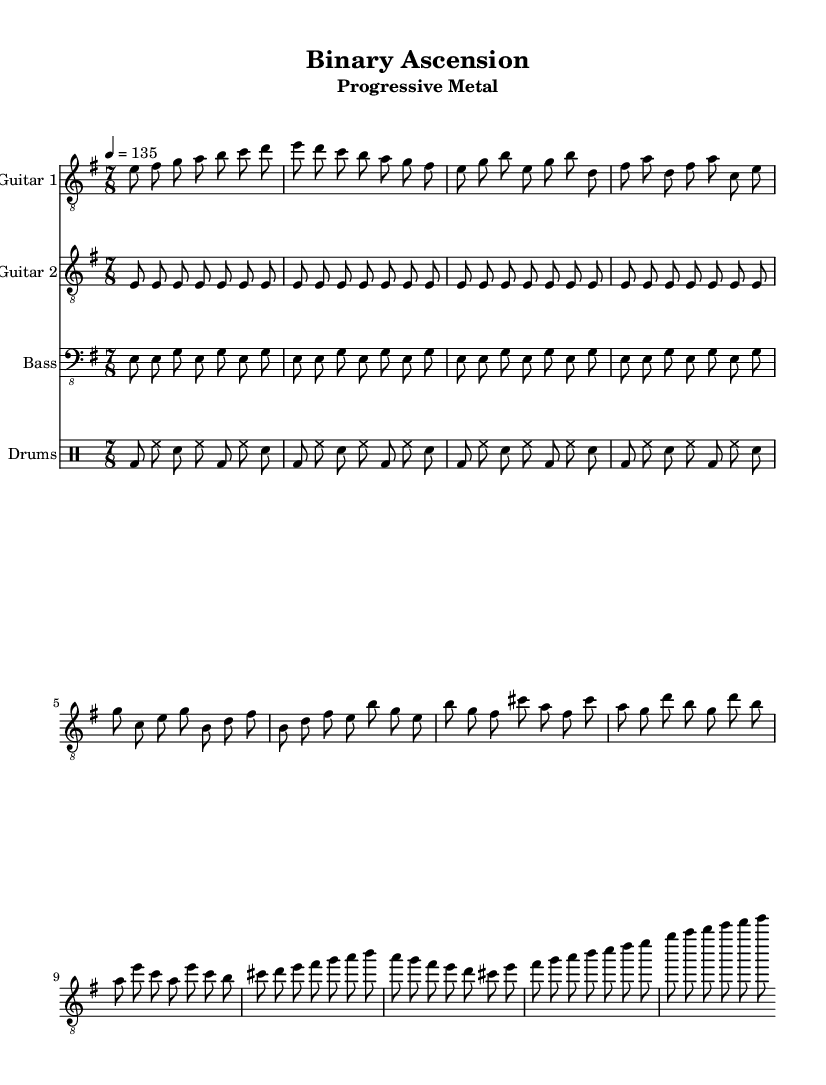What is the key signature of this music? The key signature is E minor, which has one sharp (F#). This is identified by observing the number of sharps indicated at the beginning of the staff. Since we see one sharp, we confirm it is E minor.
Answer: E minor What is the time signature of this music? The time signature is 7/8, as it is specifically notated at the beginning of the score. This indicates there are seven eighth-note beats in each measure.
Answer: 7/8 What is the tempo marking of this music? The tempo marking is quarter note equals 135, which is indicated next to the time signature. This means the music should be played at a speed of 135 beats per minute.
Answer: 135 How many measures does the verse section contain? By counting the measures in the verse section found from the guitar one part, it contains four measures. Each measure is separated by a vertical line and marked clearly in the notation.
Answer: 4 What type of guitar part is included alongside the lead guitar? The score presents a rhythm guitar part that is simplified, with the rhythm guitar defined as "Guitar 2." The part supports the lead guitar and features a repeated eighth-note pattern throughout the measures.
Answer: Rhythm guitar Which thematic element does this piece explore? The piece explores themes of technological advancement and automation, which is reflected in its complex rhythms and progressive transitions. This aligns with the progressive metal genre, which often incorporates such themes in subtext.
Answer: Technological advancement 